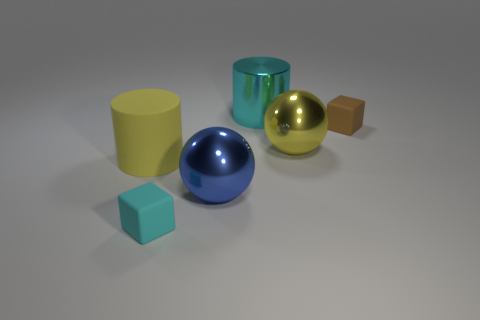Subtract all yellow spheres. How many spheres are left? 1 Subtract 1 balls. How many balls are left? 1 Add 2 large cyan shiny things. How many objects exist? 8 Subtract all cubes. How many objects are left? 4 Subtract 0 brown cylinders. How many objects are left? 6 Subtract all red blocks. Subtract all red cylinders. How many blocks are left? 2 Subtract all large purple shiny blocks. Subtract all tiny matte blocks. How many objects are left? 4 Add 1 large rubber cylinders. How many large rubber cylinders are left? 2 Add 4 small matte blocks. How many small matte blocks exist? 6 